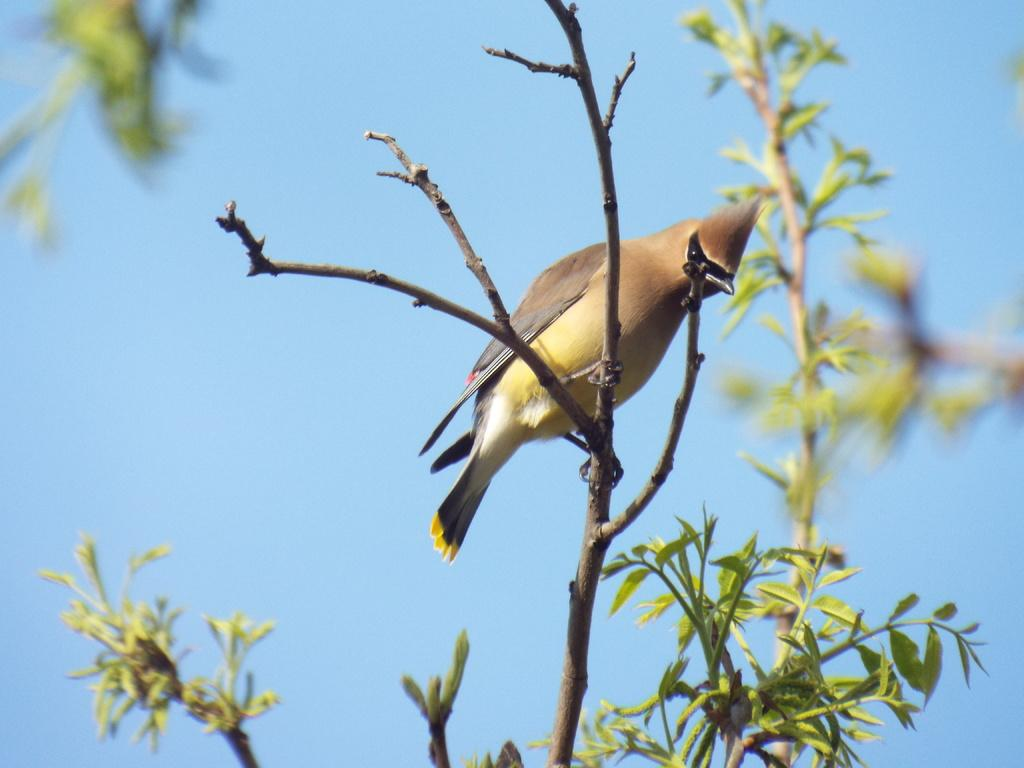What type of animal is in the image? There is a bird in the image. Where is the bird located? The bird is on a branch. What colors can be seen on the bird? The bird has brown, black, and yellow colors. What type of vegetation is visible in the image? There are green leaves visible in the image. What color is the sky in the image? The sky is blue in the image. What type of corn is being cooked in the stew in the image? There is no corn or stew present in the image; it features a bird on a branch with green leaves and a blue sky. 